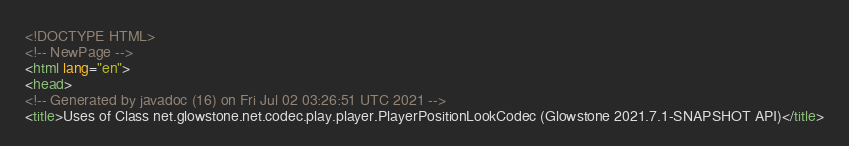Convert code to text. <code><loc_0><loc_0><loc_500><loc_500><_HTML_><!DOCTYPE HTML>
<!-- NewPage -->
<html lang="en">
<head>
<!-- Generated by javadoc (16) on Fri Jul 02 03:26:51 UTC 2021 -->
<title>Uses of Class net.glowstone.net.codec.play.player.PlayerPositionLookCodec (Glowstone 2021.7.1-SNAPSHOT API)</title></code> 